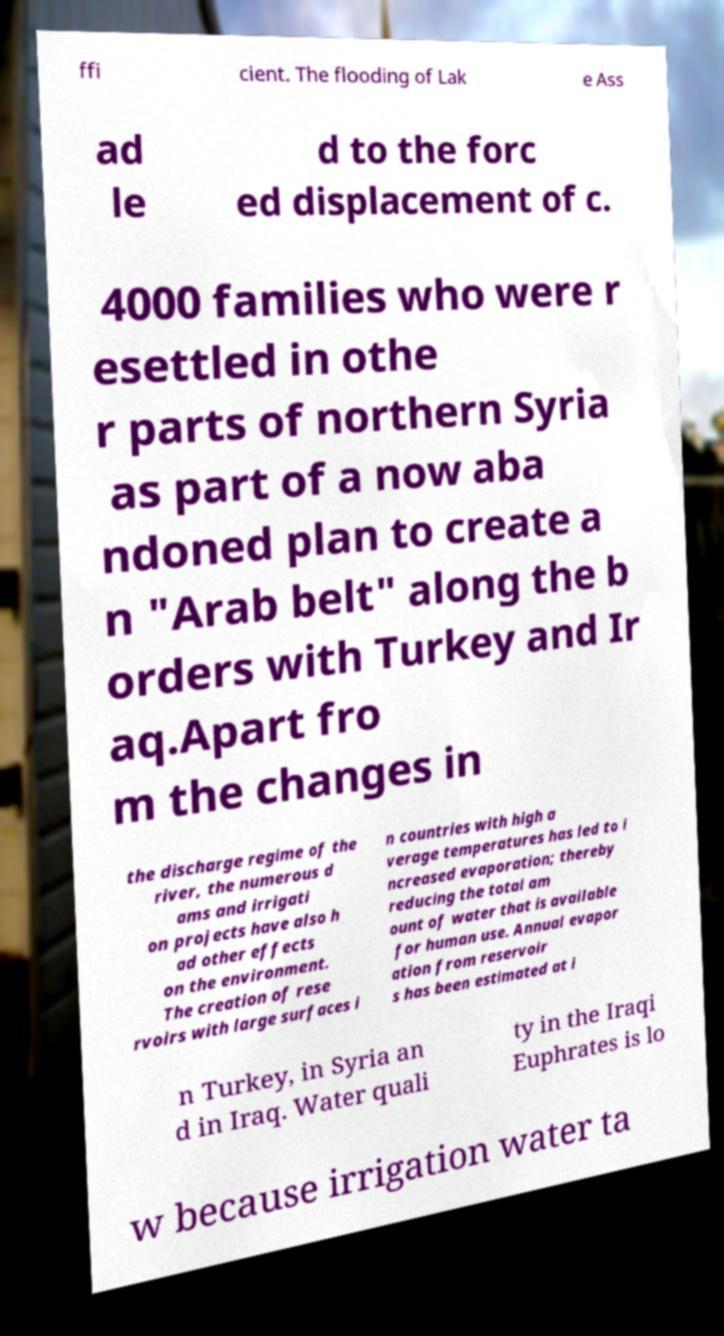There's text embedded in this image that I need extracted. Can you transcribe it verbatim? ffi cient. The flooding of Lak e Ass ad le d to the forc ed displacement of c. 4000 families who were r esettled in othe r parts of northern Syria as part of a now aba ndoned plan to create a n "Arab belt" along the b orders with Turkey and Ir aq.Apart fro m the changes in the discharge regime of the river, the numerous d ams and irrigati on projects have also h ad other effects on the environment. The creation of rese rvoirs with large surfaces i n countries with high a verage temperatures has led to i ncreased evaporation; thereby reducing the total am ount of water that is available for human use. Annual evapor ation from reservoir s has been estimated at i n Turkey, in Syria an d in Iraq. Water quali ty in the Iraqi Euphrates is lo w because irrigation water ta 